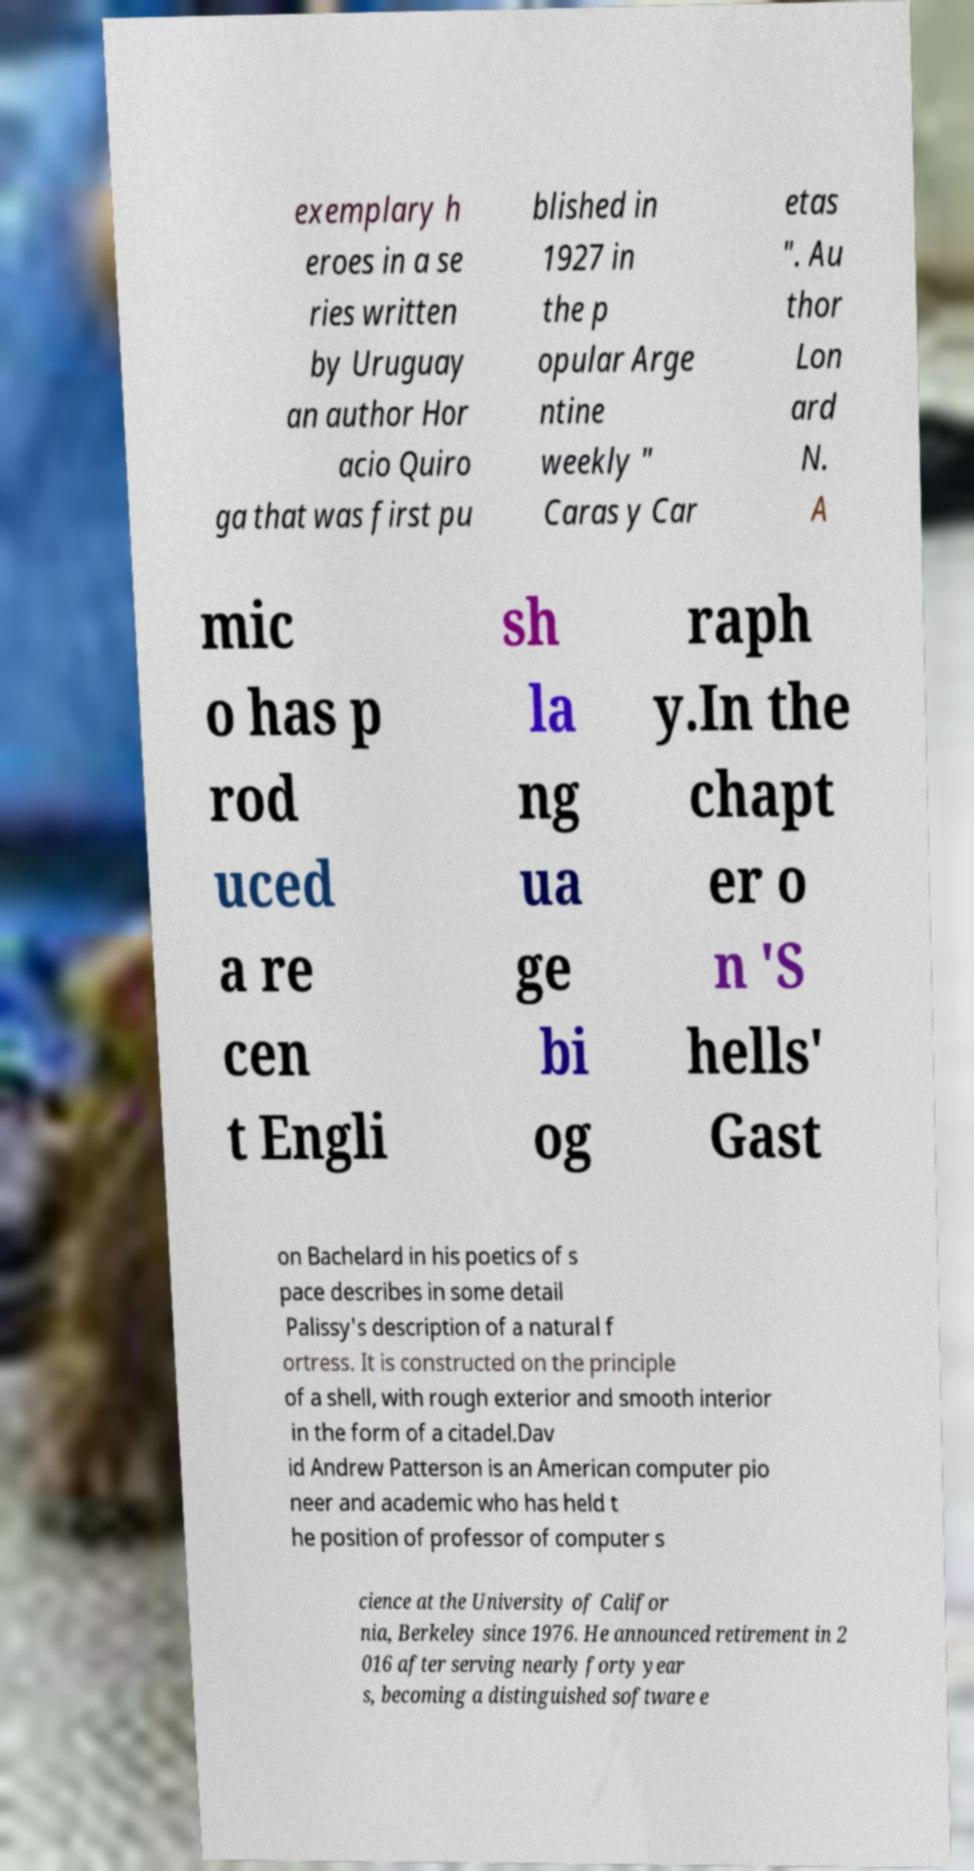Can you read and provide the text displayed in the image?This photo seems to have some interesting text. Can you extract and type it out for me? exemplary h eroes in a se ries written by Uruguay an author Hor acio Quiro ga that was first pu blished in 1927 in the p opular Arge ntine weekly " Caras y Car etas ". Au thor Lon ard N. A mic o has p rod uced a re cen t Engli sh la ng ua ge bi og raph y.In the chapt er o n 'S hells' Gast on Bachelard in his poetics of s pace describes in some detail Palissy's description of a natural f ortress. It is constructed on the principle of a shell, with rough exterior and smooth interior in the form of a citadel.Dav id Andrew Patterson is an American computer pio neer and academic who has held t he position of professor of computer s cience at the University of Califor nia, Berkeley since 1976. He announced retirement in 2 016 after serving nearly forty year s, becoming a distinguished software e 